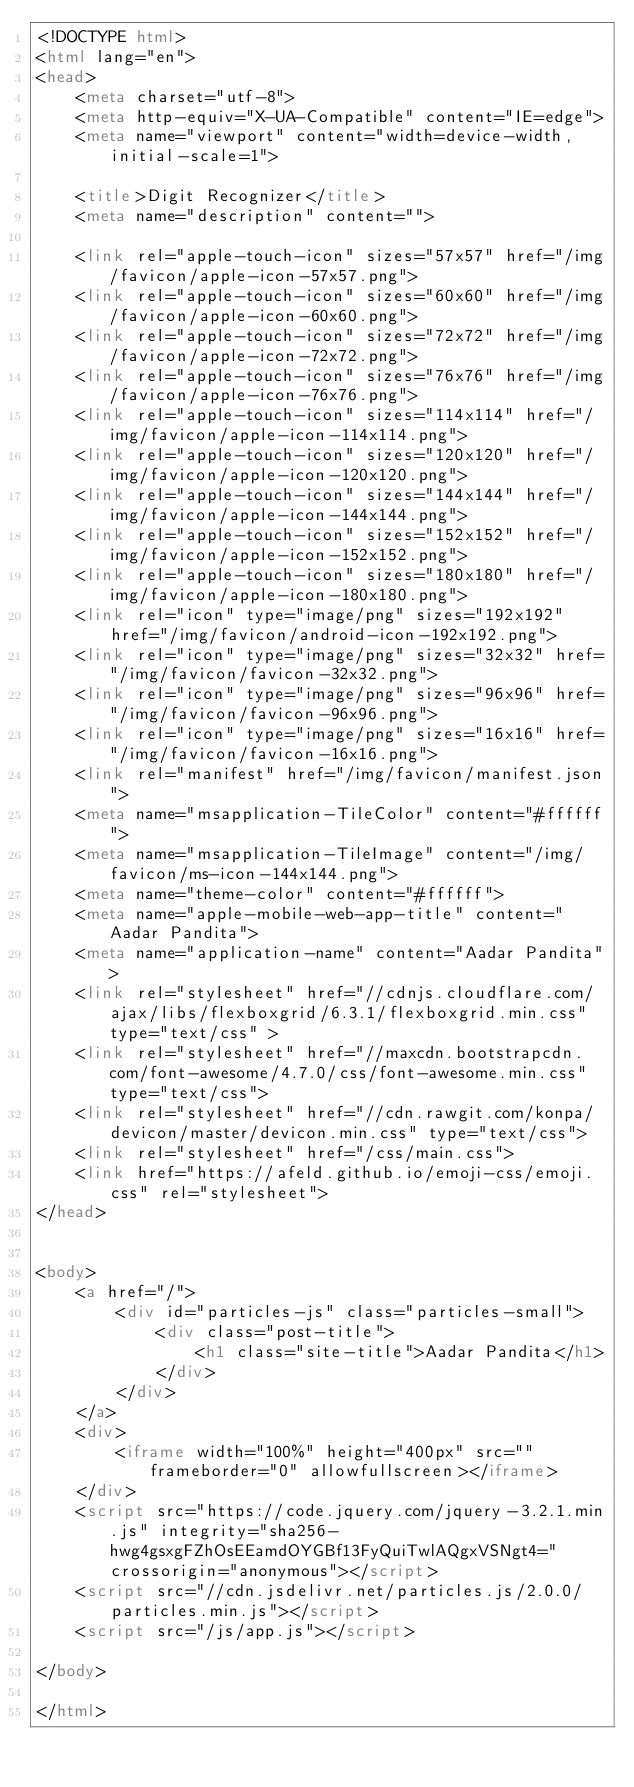<code> <loc_0><loc_0><loc_500><loc_500><_HTML_><!DOCTYPE html>
<html lang="en">
<head>
    <meta charset="utf-8">
    <meta http-equiv="X-UA-Compatible" content="IE=edge">
    <meta name="viewport" content="width=device-width, initial-scale=1">
  
    <title>Digit Recognizer</title>
    <meta name="description" content="">
  
    <link rel="apple-touch-icon" sizes="57x57" href="/img/favicon/apple-icon-57x57.png">
    <link rel="apple-touch-icon" sizes="60x60" href="/img/favicon/apple-icon-60x60.png">
    <link rel="apple-touch-icon" sizes="72x72" href="/img/favicon/apple-icon-72x72.png">
    <link rel="apple-touch-icon" sizes="76x76" href="/img/favicon/apple-icon-76x76.png">
    <link rel="apple-touch-icon" sizes="114x114" href="/img/favicon/apple-icon-114x114.png">
    <link rel="apple-touch-icon" sizes="120x120" href="/img/favicon/apple-icon-120x120.png">
    <link rel="apple-touch-icon" sizes="144x144" href="/img/favicon/apple-icon-144x144.png">
    <link rel="apple-touch-icon" sizes="152x152" href="/img/favicon/apple-icon-152x152.png">
    <link rel="apple-touch-icon" sizes="180x180" href="/img/favicon/apple-icon-180x180.png">
    <link rel="icon" type="image/png" sizes="192x192"  href="/img/favicon/android-icon-192x192.png">
    <link rel="icon" type="image/png" sizes="32x32" href="/img/favicon/favicon-32x32.png">
    <link rel="icon" type="image/png" sizes="96x96" href="/img/favicon/favicon-96x96.png">
    <link rel="icon" type="image/png" sizes="16x16" href="/img/favicon/favicon-16x16.png">
    <link rel="manifest" href="/img/favicon/manifest.json">
    <meta name="msapplication-TileColor" content="#ffffff">
    <meta name="msapplication-TileImage" content="/img/favicon/ms-icon-144x144.png">
    <meta name="theme-color" content="#ffffff">
    <meta name="apple-mobile-web-app-title" content="Aadar Pandita">
    <meta name="application-name" content="Aadar Pandita">
    <link rel="stylesheet" href="//cdnjs.cloudflare.com/ajax/libs/flexboxgrid/6.3.1/flexboxgrid.min.css" type="text/css" >
    <link rel="stylesheet" href="//maxcdn.bootstrapcdn.com/font-awesome/4.7.0/css/font-awesome.min.css" type="text/css">
    <link rel="stylesheet" href="//cdn.rawgit.com/konpa/devicon/master/devicon.min.css" type="text/css">
    <link rel="stylesheet" href="/css/main.css">
    <link href="https://afeld.github.io/emoji-css/emoji.css" rel="stylesheet">
</head>


<body>
    <a href="/">
        <div id="particles-js" class="particles-small">
            <div class="post-title">
                <h1 class="site-title">Aadar Pandita</h1>
            </div>
        </div>
    </a>
    <div>
        <iframe width="100%" height="400px" src="" frameborder="0" allowfullscreen></iframe>
    </div>
    <script src="https://code.jquery.com/jquery-3.2.1.min.js" integrity="sha256-hwg4gsxgFZhOsEEamdOYGBf13FyQuiTwlAQgxVSNgt4=" crossorigin="anonymous"></script>
    <script src="//cdn.jsdelivr.net/particles.js/2.0.0/particles.min.js"></script>
    <script src="/js/app.js"></script>

</body>

</html>
</code> 